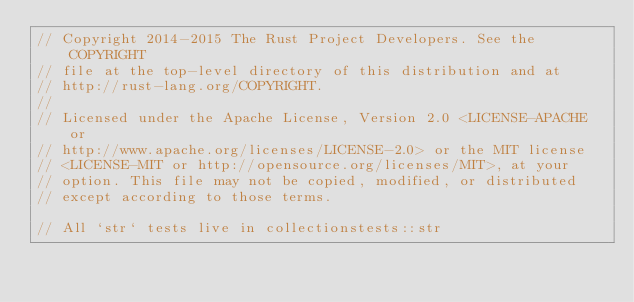<code> <loc_0><loc_0><loc_500><loc_500><_Rust_>// Copyright 2014-2015 The Rust Project Developers. See the COPYRIGHT
// file at the top-level directory of this distribution and at
// http://rust-lang.org/COPYRIGHT.
//
// Licensed under the Apache License, Version 2.0 <LICENSE-APACHE or
// http://www.apache.org/licenses/LICENSE-2.0> or the MIT license
// <LICENSE-MIT or http://opensource.org/licenses/MIT>, at your
// option. This file may not be copied, modified, or distributed
// except according to those terms.

// All `str` tests live in collectionstests::str
</code> 